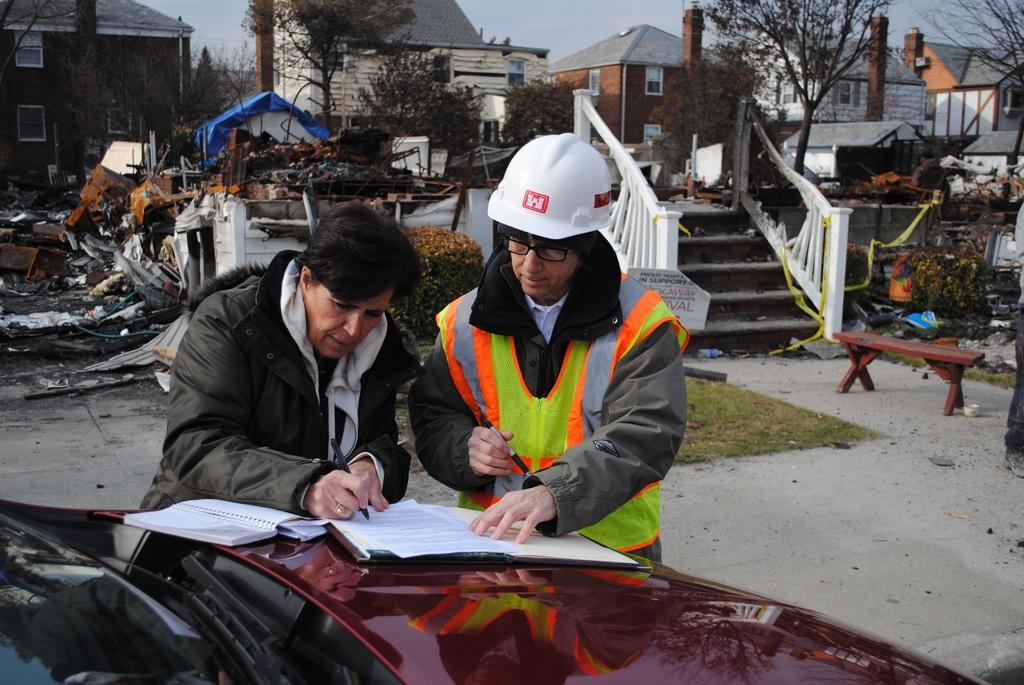How would you summarize this image in a sentence or two? This image consists of two persons. On the left, the person is wearing a black jacket and writing. At the bottom, there is a car. In the background, there are many houses and trees. And we can see a dump behind the persons. On the right, there is a bench. At the top, there is a sky. 